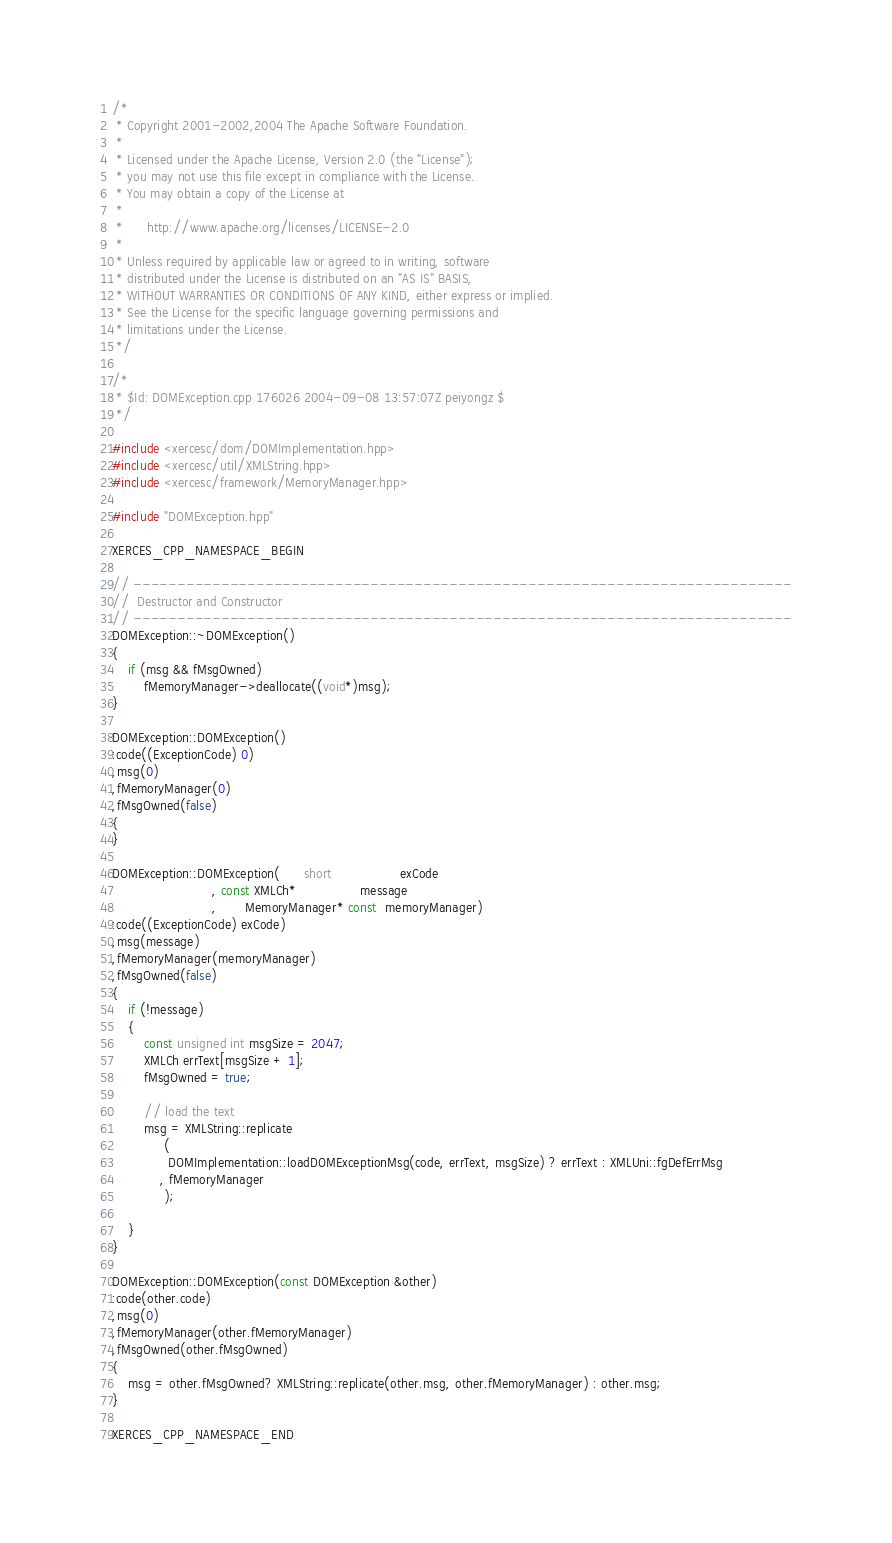Convert code to text. <code><loc_0><loc_0><loc_500><loc_500><_C++_>/*
 * Copyright 2001-2002,2004 The Apache Software Foundation.
 * 
 * Licensed under the Apache License, Version 2.0 (the "License");
 * you may not use this file except in compliance with the License.
 * You may obtain a copy of the License at
 * 
 *      http://www.apache.org/licenses/LICENSE-2.0
 * 
 * Unless required by applicable law or agreed to in writing, software
 * distributed under the License is distributed on an "AS IS" BASIS,
 * WITHOUT WARRANTIES OR CONDITIONS OF ANY KIND, either express or implied.
 * See the License for the specific language governing permissions and
 * limitations under the License.
 */

/*
 * $Id: DOMException.cpp 176026 2004-09-08 13:57:07Z peiyongz $
 */

#include <xercesc/dom/DOMImplementation.hpp>
#include <xercesc/util/XMLString.hpp>
#include <xercesc/framework/MemoryManager.hpp>

#include "DOMException.hpp"

XERCES_CPP_NAMESPACE_BEGIN

// ---------------------------------------------------------------------------
//  Destructor and Constructor
// ---------------------------------------------------------------------------
DOMException::~DOMException()
{
    if (msg && fMsgOwned)
        fMemoryManager->deallocate((void*)msg);
}

DOMException::DOMException()
:code((ExceptionCode) 0)
,msg(0)
,fMemoryManager(0)
,fMsgOwned(false)
{      
}

DOMException::DOMException(      short                 exCode
                         , const XMLCh*                message
                         ,       MemoryManager* const  memoryManager)
:code((ExceptionCode) exCode)
,msg(message)
,fMemoryManager(memoryManager)
,fMsgOwned(false)
{  
    if (!message)
    {
        const unsigned int msgSize = 2047;
        XMLCh errText[msgSize + 1];
        fMsgOwned = true;

        // load the text
        msg = XMLString::replicate
             ( 
              DOMImplementation::loadDOMExceptionMsg(code, errText, msgSize) ? errText : XMLUni::fgDefErrMsg
            , fMemoryManager
             );

    }
}

DOMException::DOMException(const DOMException &other)
:code(other.code)
,msg(0)
,fMemoryManager(other.fMemoryManager)
,fMsgOwned(other.fMsgOwned)
{
    msg = other.fMsgOwned? XMLString::replicate(other.msg, other.fMemoryManager) : other.msg;
}

XERCES_CPP_NAMESPACE_END

</code> 